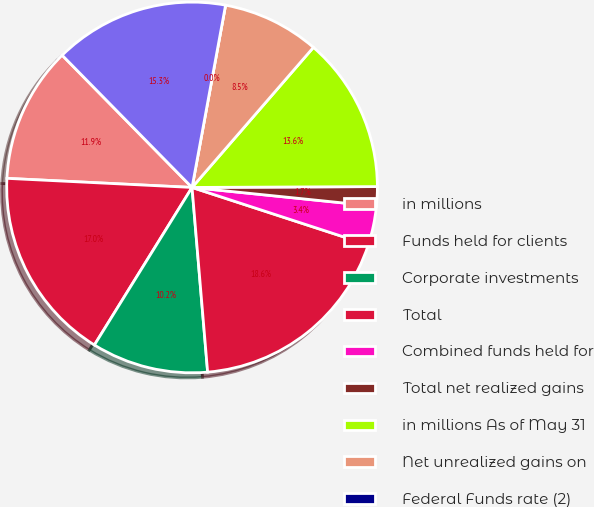Convert chart. <chart><loc_0><loc_0><loc_500><loc_500><pie_chart><fcel>in millions<fcel>Funds held for clients<fcel>Corporate investments<fcel>Total<fcel>Combined funds held for<fcel>Total net realized gains<fcel>in millions As of May 31<fcel>Net unrealized gains on<fcel>Federal Funds rate (2)<fcel>Total fair value of<nl><fcel>11.86%<fcel>16.95%<fcel>10.17%<fcel>18.64%<fcel>3.39%<fcel>1.7%<fcel>13.56%<fcel>8.47%<fcel>0.0%<fcel>15.25%<nl></chart> 